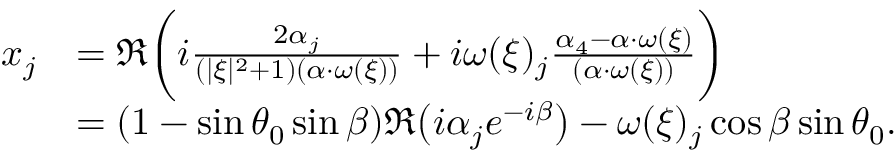<formula> <loc_0><loc_0><loc_500><loc_500>\begin{array} { r l } { x _ { j } } & { = \Re \left ( i \frac { 2 \alpha _ { j } } { ( | \xi | ^ { 2 } + 1 ) ( \alpha \cdot \omega ( \xi ) ) } + i \omega ( \xi ) _ { j } \frac { \alpha _ { 4 } - \alpha \cdot \omega ( \xi ) } { ( \alpha \cdot \omega ( \xi ) ) } \right ) } \\ & { = ( 1 - \sin \theta _ { 0 } \sin \beta ) \Re \left ( i \alpha _ { j } e ^ { - i \beta } \right ) - \omega ( \xi ) _ { j } \cos \beta \sin \theta _ { 0 } . } \end{array}</formula> 